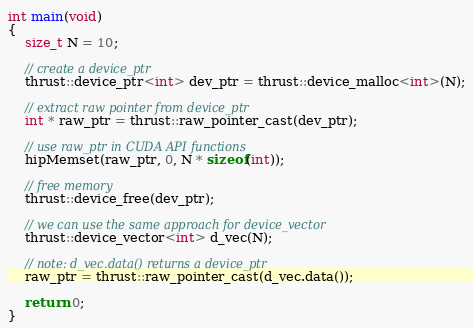<code> <loc_0><loc_0><loc_500><loc_500><_Cuda_>int main(void)
{
    size_t N = 10;

    // create a device_ptr 
    thrust::device_ptr<int> dev_ptr = thrust::device_malloc<int>(N);
     
    // extract raw pointer from device_ptr
    int * raw_ptr = thrust::raw_pointer_cast(dev_ptr);

    // use raw_ptr in CUDA API functions
    hipMemset(raw_ptr, 0, N * sizeof(int));

    // free memory
    thrust::device_free(dev_ptr);
    
    // we can use the same approach for device_vector
    thrust::device_vector<int> d_vec(N);

    // note: d_vec.data() returns a device_ptr
    raw_ptr = thrust::raw_pointer_cast(d_vec.data());

    return 0;
}
</code> 